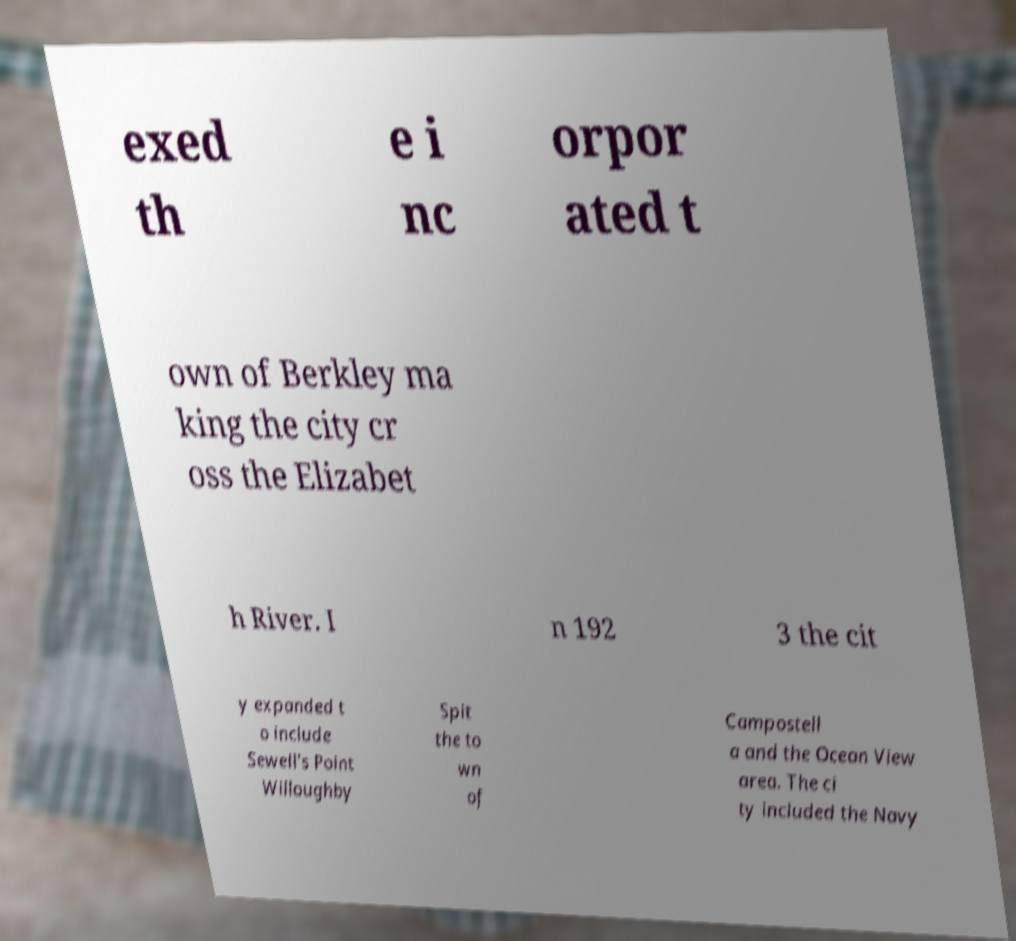Could you extract and type out the text from this image? exed th e i nc orpor ated t own of Berkley ma king the city cr oss the Elizabet h River. I n 192 3 the cit y expanded t o include Sewell's Point Willoughby Spit the to wn of Campostell a and the Ocean View area. The ci ty included the Navy 